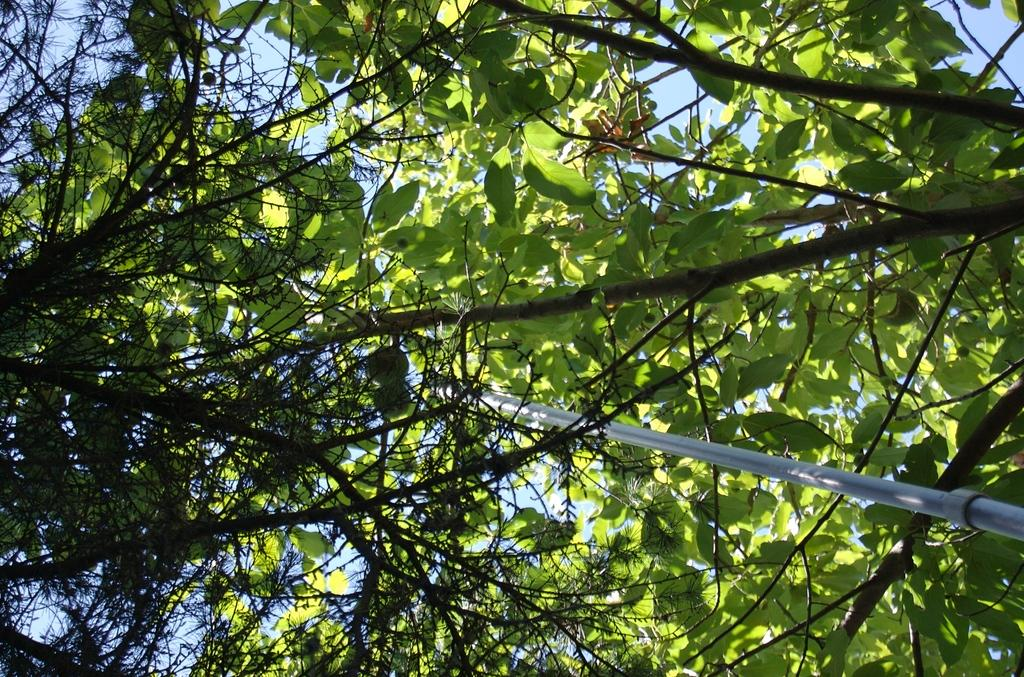What type of vegetation is visible in the image? There are branches of a tree in the image. What is the color of the leaves on the tree? The tree has green leaves. What other object can be seen in the image besides the tree? There is a pole in between the tree branches. How many people are in the group that is looking at the tree in the image? There is no group of people present in the image; it only features the tree and the pole. What color is the eye of the bird perched on the tree in the image? There is no bird or any other living creature present in the image. 